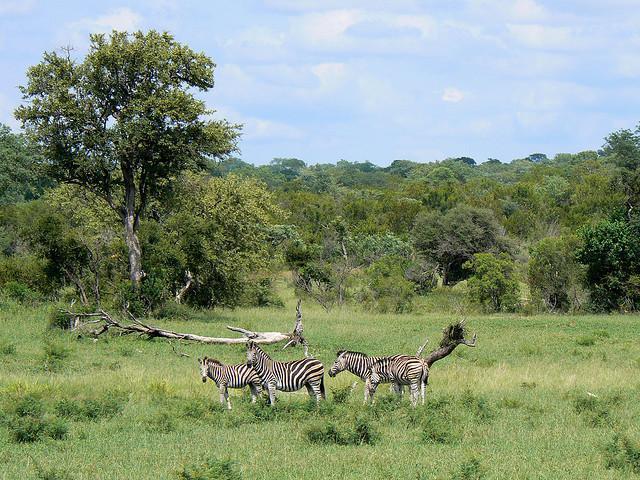How many zebras standing?
Give a very brief answer. 3. How many zebras are there?
Give a very brief answer. 2. 